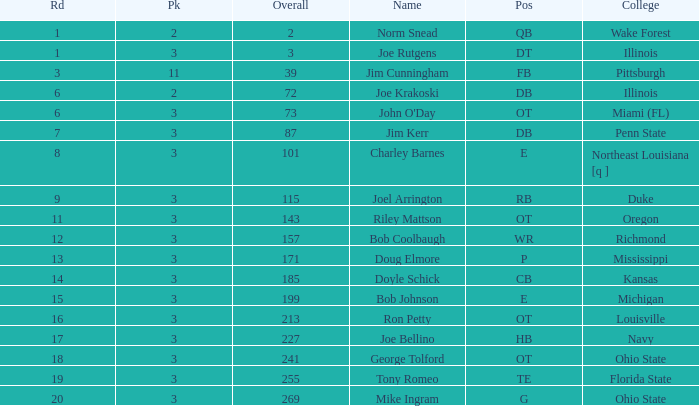How many overalls have charley barnes as the name, with a pick less than 3? None. 